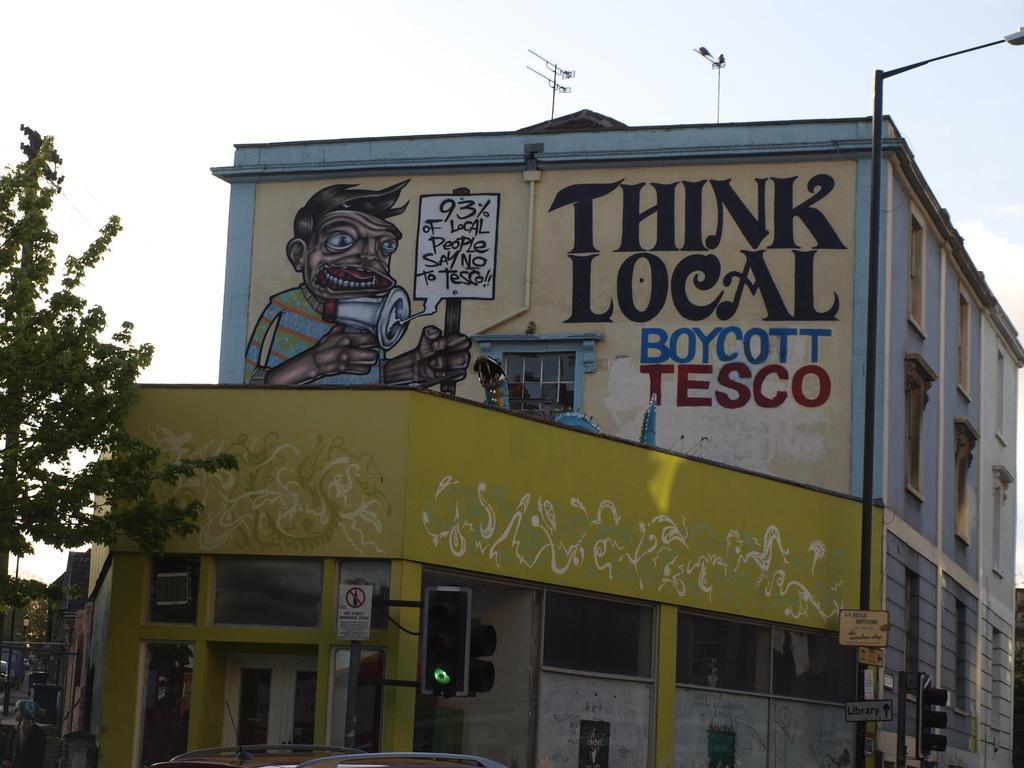Describe this image in one or two sentences. This image consists of buildings along with windows. At the top, there is sky. On the left, we can see a tree. 